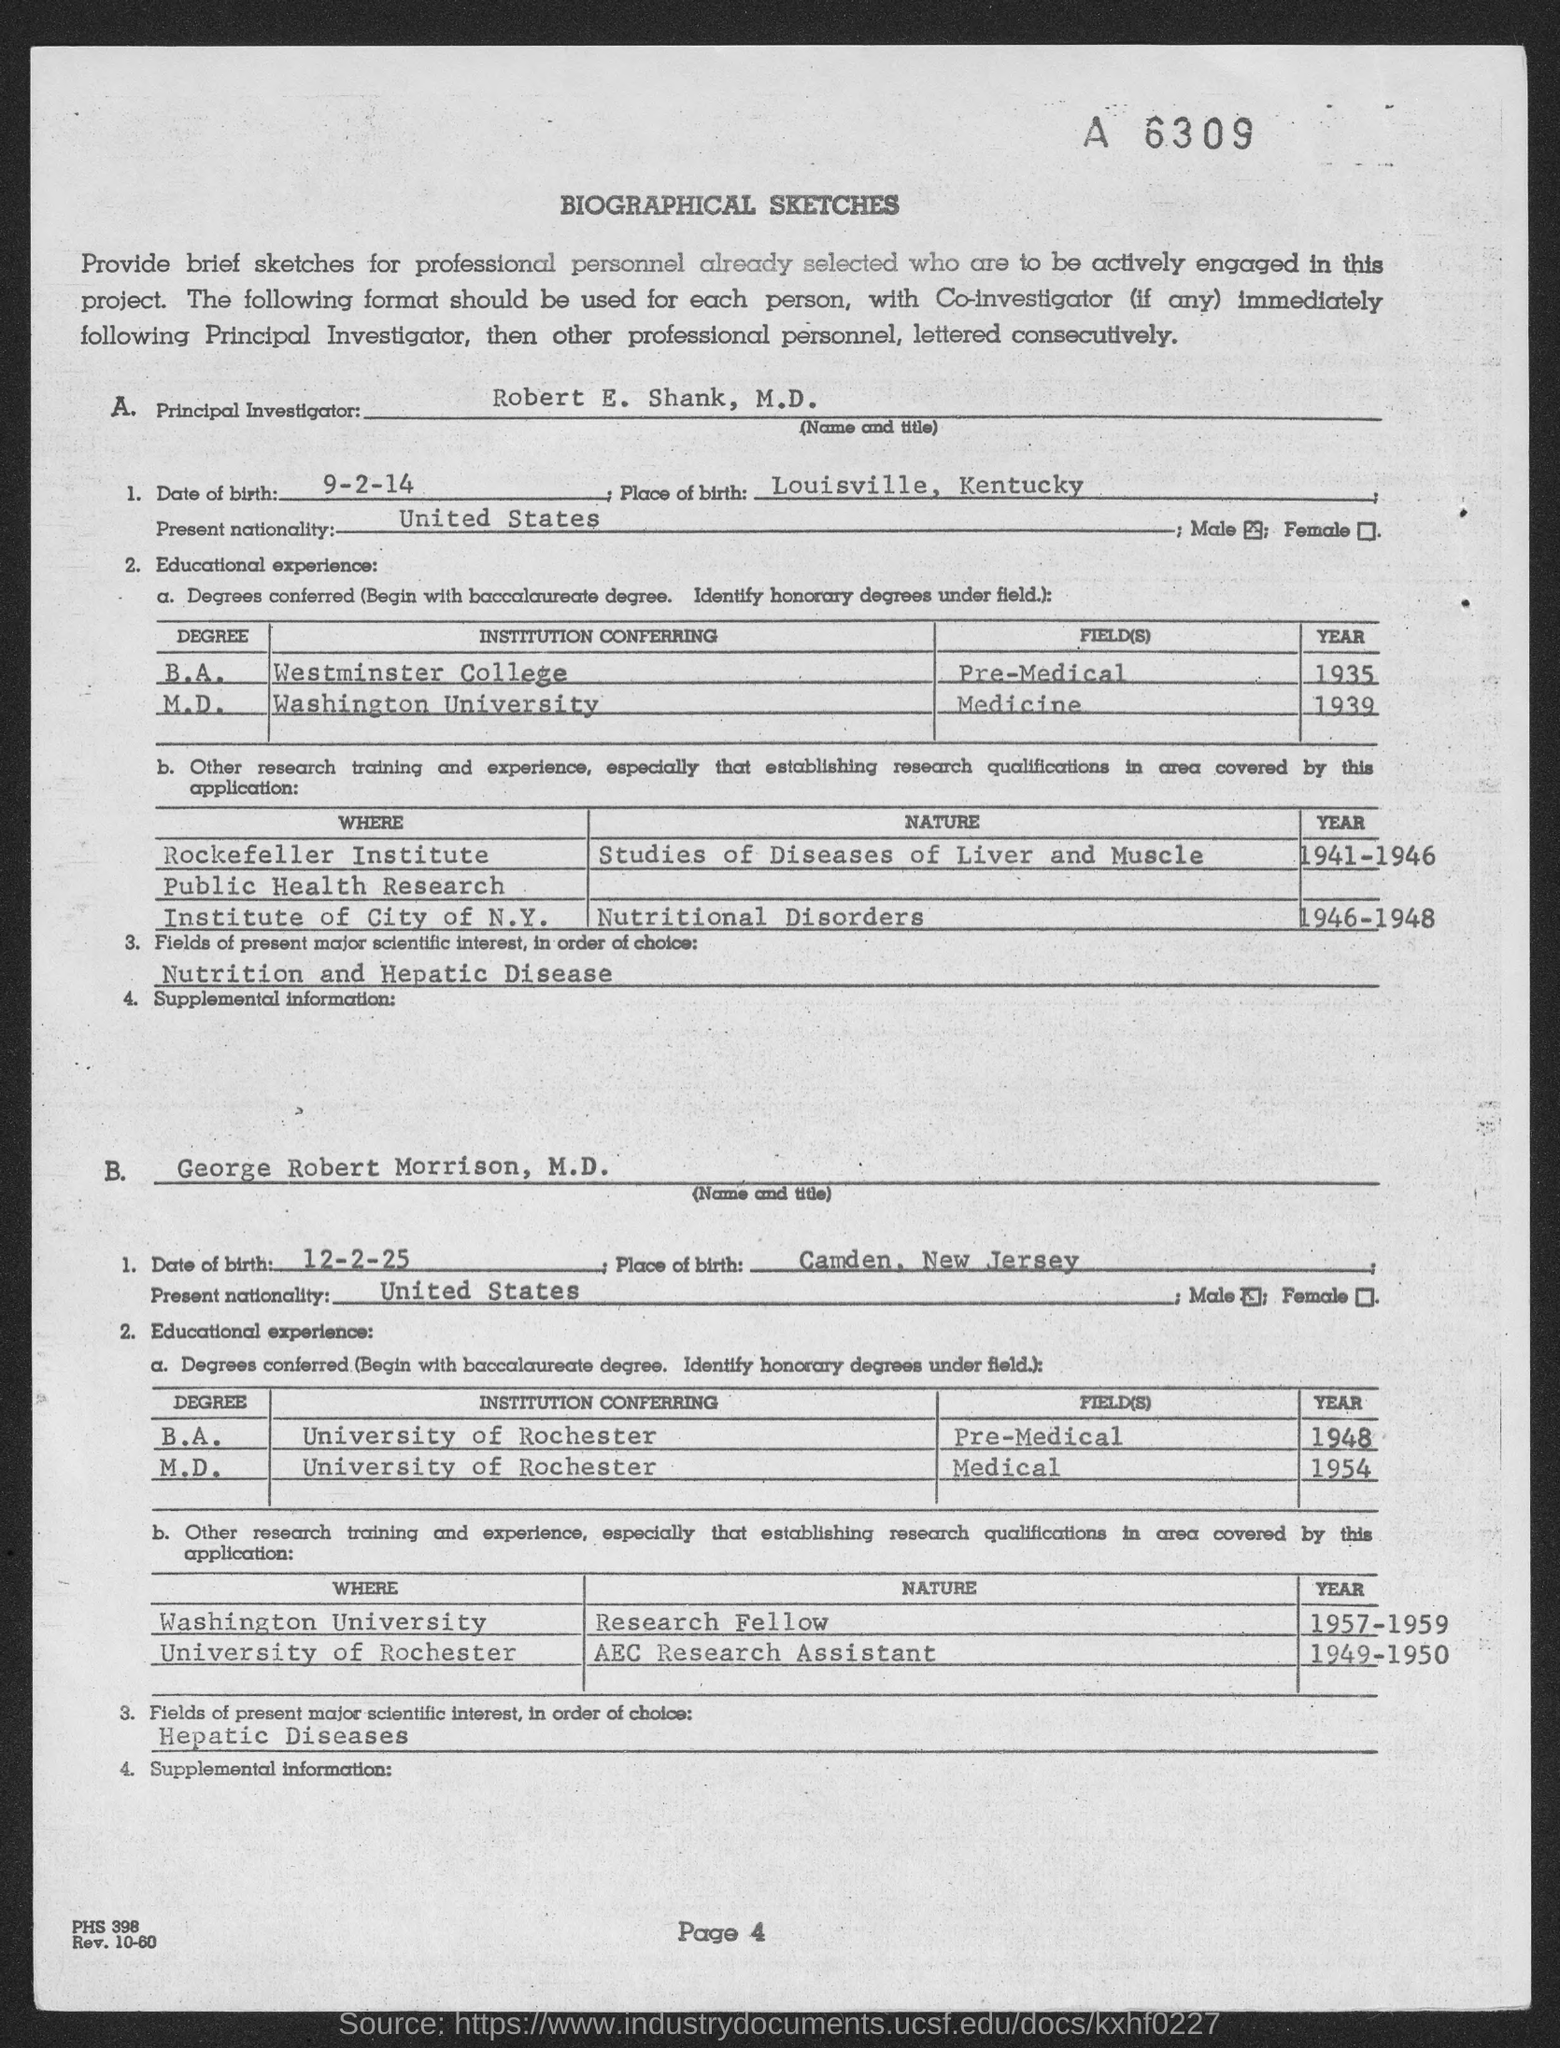What is the page number?
Your answer should be compact. 4. What is the Date of Birth of Robert E. Shank?
Offer a very short reply. 9-2-14. Which is the Place of Birth of Robert E. Shank?
Offer a very short reply. Louisville, Kentucky. What is the Date of Birth of George Robert Morrison?
Offer a very short reply. 12-2-25. Which is the Place of Birth of George Robert Morrison?
Provide a short and direct response. Camden, New Jersey. 